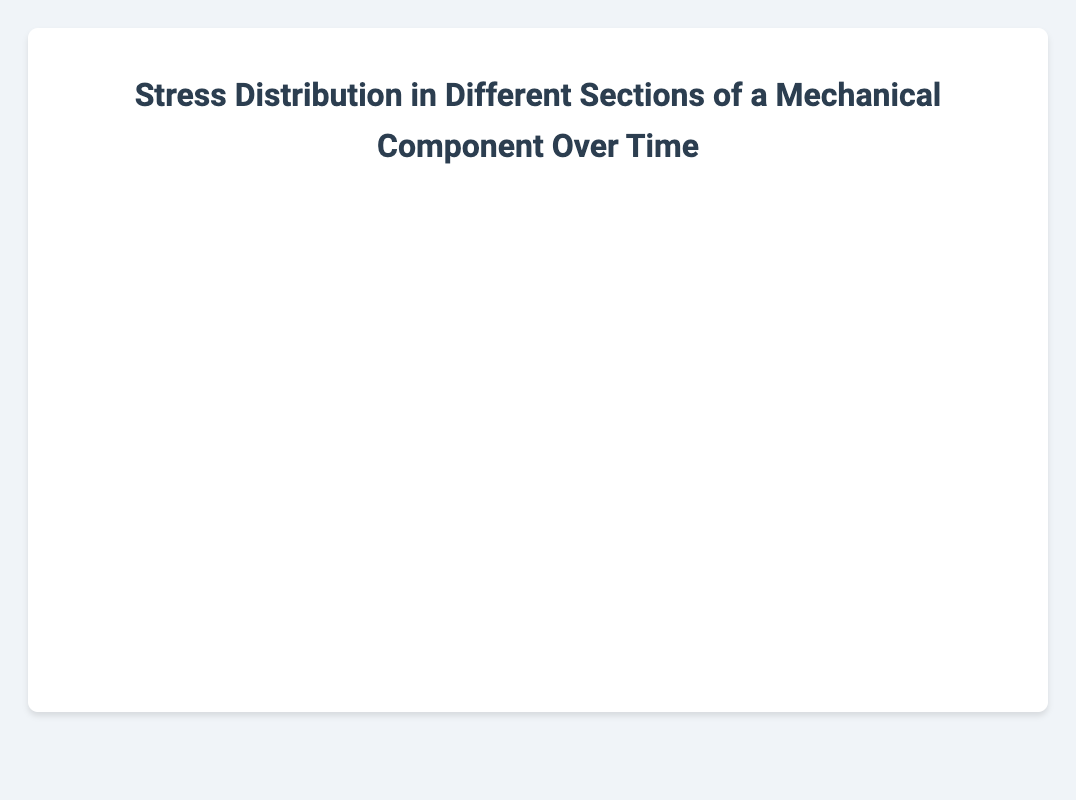What is the title of the chart? The title of the chart is displayed at the top, which is "Stress Distribution in Different Sections of a Mechanical Component Over Time."
Answer: Stress Distribution in Different Sections of a Mechanical Component Over Time What's the value of stress in the Bolt Hole section at 03:00? Find the Bolt Hole data point corresponding to 03:00, which is 115 MPa.
Answer: 115 MPa Which section has the highest initial stress value and what is it? The initial time point is 2023-10-01T00:00:00Z. Compare the stress values: Bolt Hole (120.5), Fillet Radius (93.2), Notch Area (150.0), and Base Plate (80.4). The Notch Area has the highest value of 150.0 MPa.
Answer: Notch Area, 150.0 MPa How does the stress in the Fillet Radius change from 00:00 to 06:00? Check the stress values for the Fillet Radius at 00:00 and 06:00. At 00:00, it is 93.2 MPa and at 06:00, it is 105.0 MPa. The change is an increase.
Answer: Increase from 93.2 MPa to 105.0 MPa What is the average stress value in the Notch Area over the entire period? Sum all the stress values for the Notch Area (150.0, 147.8, 145.2, 143.0, 141.6, 140.3, 138.7) and divide by the number of time points (7). The total is 1006.6 and the average is 1006.6/7 = 143.8 MPa.
Answer: 143.8 MPa Which section shows the most significant increase in stress over time? Compare the changes in stress from 00:00 to 06:00 across all sections: Bolt Hole (120.5 to 109.0), Fillet Radius (93.2 to 105.0), Notch Area (150.0 to 138.7), and Base Plate (80.4 to 85.7). The most significant increase is in the Fillet Radius, which increases by 11.8 MPa.
Answer: Fillet Radius What is the total stress in all sections at 05:00? Sum the stress values for all sections at 05:00: Bolt Hole (111.5), Fillet Radius (102.8), Notch Area (140.3), Base Plate (84.0). The total is 111.5 + 102.8 + 140.3 + 84.0 = 438.6 MPa.
Answer: 438.6 MPa Does the stress in the Base Plate generally trend upwards or downwards over time? Observe the stress values in the Base Plate: 80.4, 82.3, 79.9, 81.7, 83.2, 84.0, 85.7. Overall, the trend is upwards.
Answer: Upwards Which section has the smallest variance in stress over the period? Calculate the variance in stress values for each section. The section with the least change in values over time indicates the smallest variance. Notch Area shows a close value range indicating it has the smallest variance.
Answer: Notch Area How does the sum of stress values in all sections change from 00:00 to 06:00? Calculate the sum of all sections at 00:00 (120.5 + 93.2 + 150.0 + 80.4 = 444.1) and at 06:00 (109.0 + 105.0 + 138.7 + 85.7 = 438.4). The sum decreases from 444.1 MPa to 438.4 MPa.
Answer: Decreases from 444.1 MPa to 438.4 MPa 